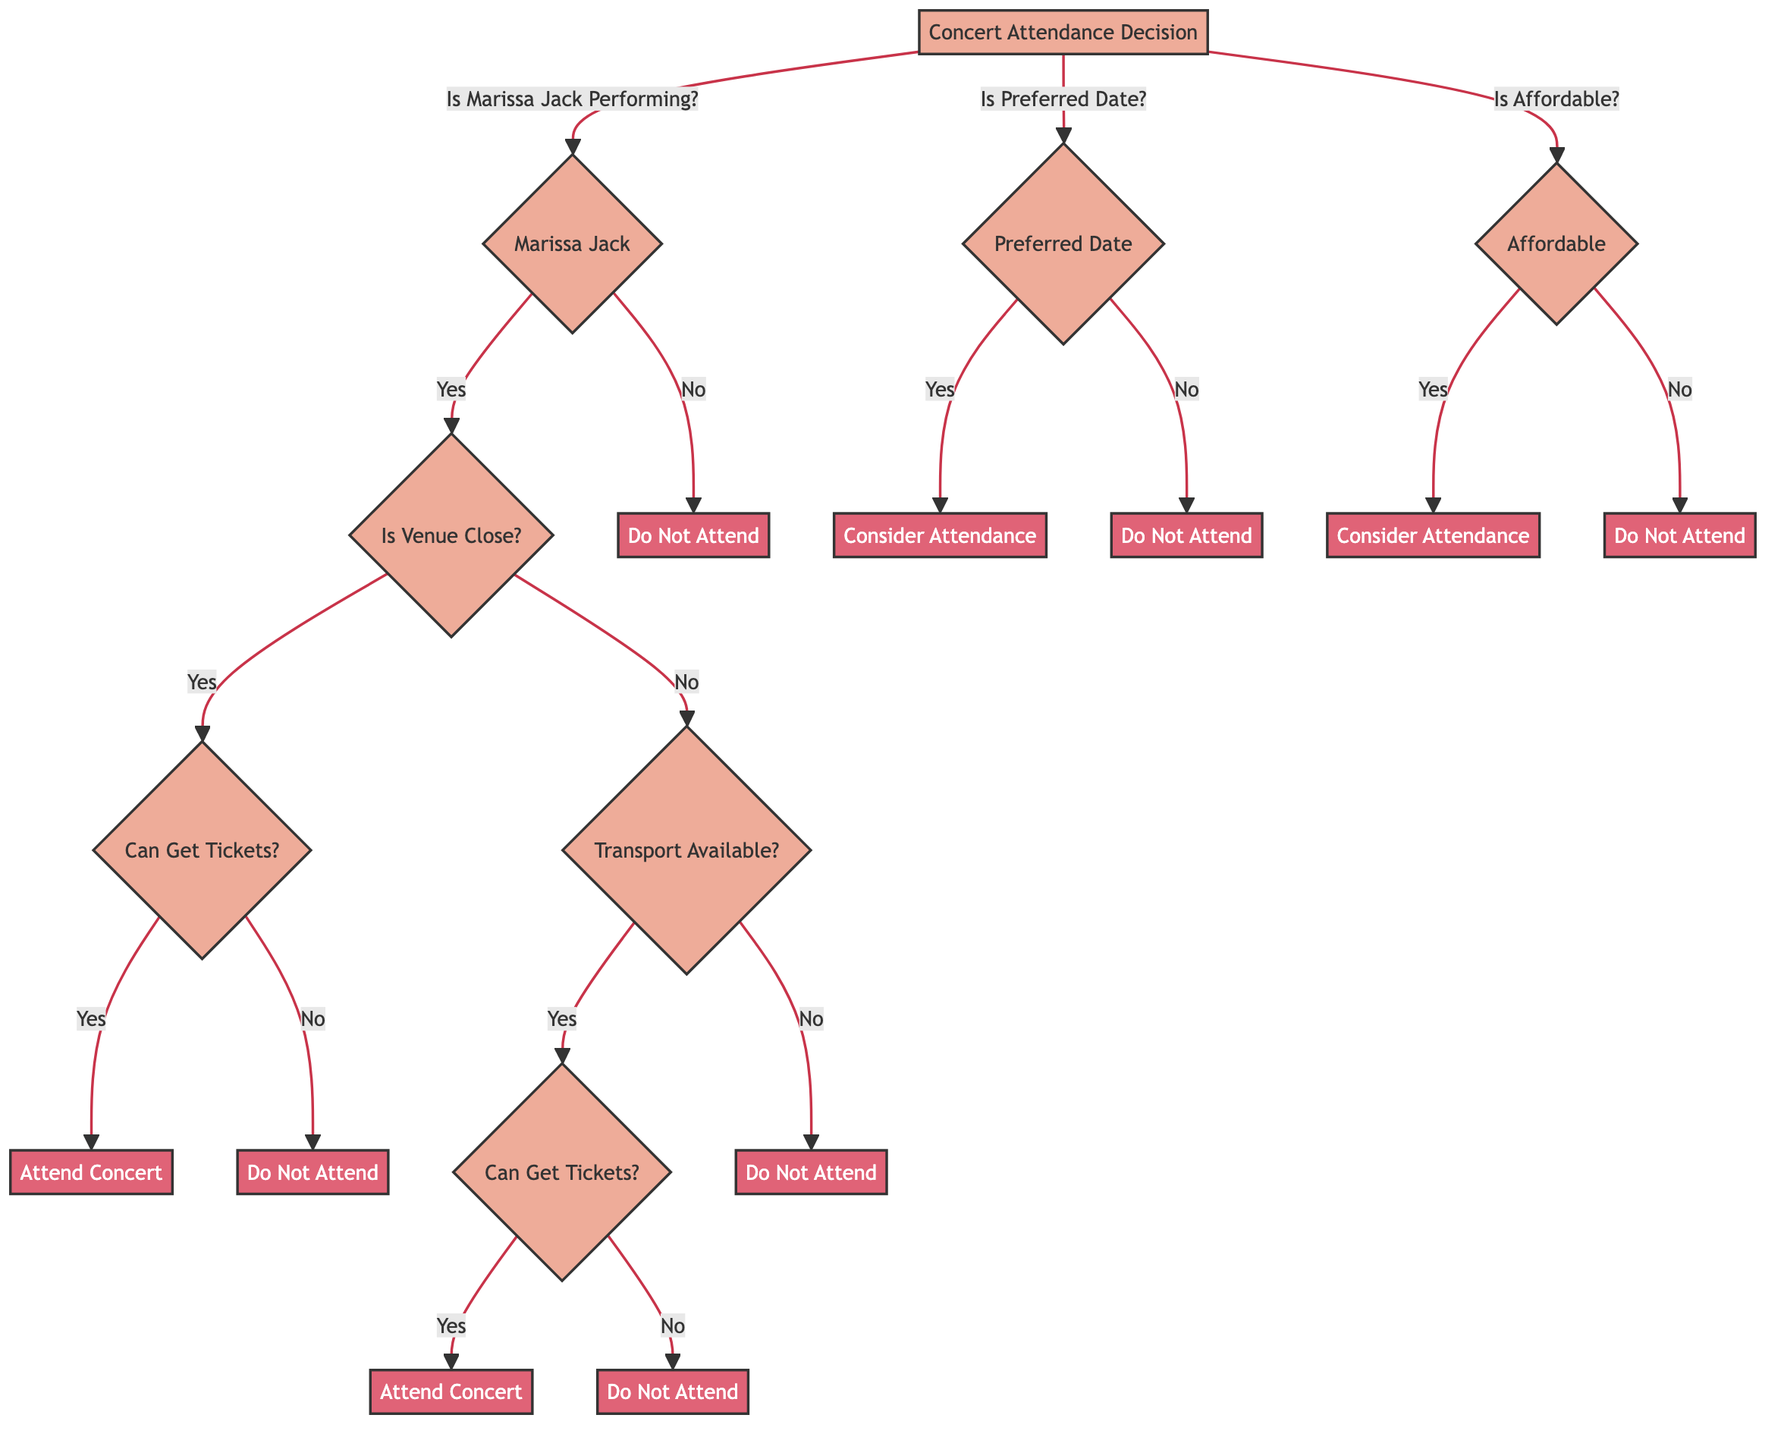What is the output if Marissa Jack is not performing? If Marissa Jack is not performing, we directly reach the "Do Not Attend" outcome, as there's no alternative route that allows attendance without her performance.
Answer: Do Not Attend What are the three conditions checked if Marissa Jack is performing? The three conditions checked are: Whether the venue is close, whether tickets can be obtained, and whether transport is available if the venue is not close.
Answer: Is Venue Close, Can Get Tickets, Transport Available What is the outcome if the venue is far and transport is not available? If the venue is far and transport is not available, we reach the "Do Not Attend" outcome since there are no means to attend the concert.
Answer: Do Not Attend How many total outcomes are there in the diagram? There are a total of five outcomes in the diagram: "Attend Concert" (twice) and "Do Not Attend" (three times).
Answer: Five What happens if the preferred date condition is met? If the preferred date condition is met, we proceed to the "Consider Attendance" outcome without further conditions, as it indicates a potential willingness to attend.
Answer: Consider Attendance What is the decision made if tickets cannot be acquired but the venue is close? If the venue is close but tickets cannot be acquired, the decision leads to the "Do Not Attend" outcome since the unavailability of tickets prevents attendance.
Answer: Do Not Attend What determines whether to consider attending in the second section of conditions? In the second section, whether to consider attending depends on if the date is preferred; if yes, it leads to the "Consider Attendance" outcome.
Answer: Consider Attendance In which circumstance would you attend the concert? The concert is attended if Marissa Jack is performing, the venue is close or transport is available, and tickets can be obtained.
Answer: Attend Concert 